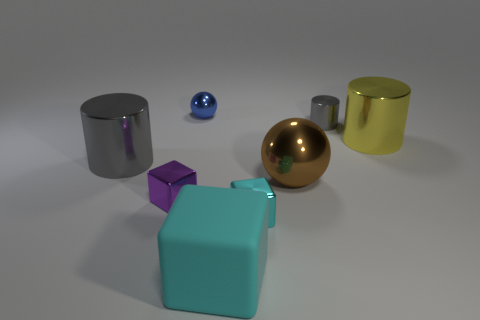Add 1 small yellow matte cylinders. How many objects exist? 9 Subtract all balls. How many objects are left? 6 Add 6 big blue cubes. How many big blue cubes exist? 6 Subtract 0 green cubes. How many objects are left? 8 Subtract all matte blocks. Subtract all small cyan spheres. How many objects are left? 7 Add 6 shiny cylinders. How many shiny cylinders are left? 9 